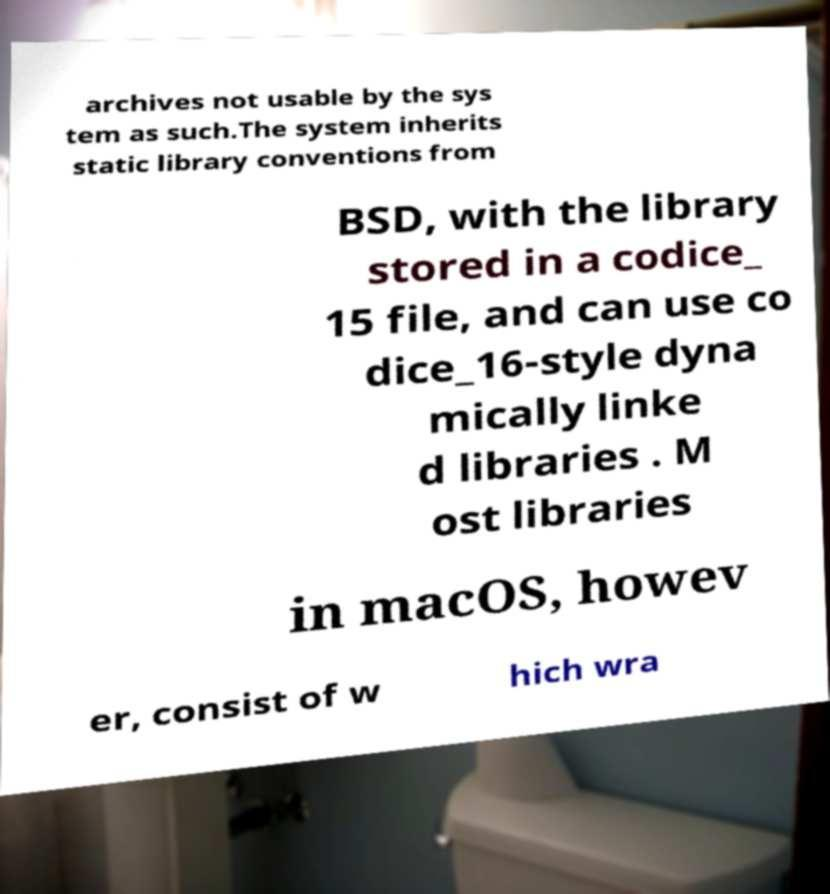Could you assist in decoding the text presented in this image and type it out clearly? archives not usable by the sys tem as such.The system inherits static library conventions from BSD, with the library stored in a codice_ 15 file, and can use co dice_16-style dyna mically linke d libraries . M ost libraries in macOS, howev er, consist of w hich wra 